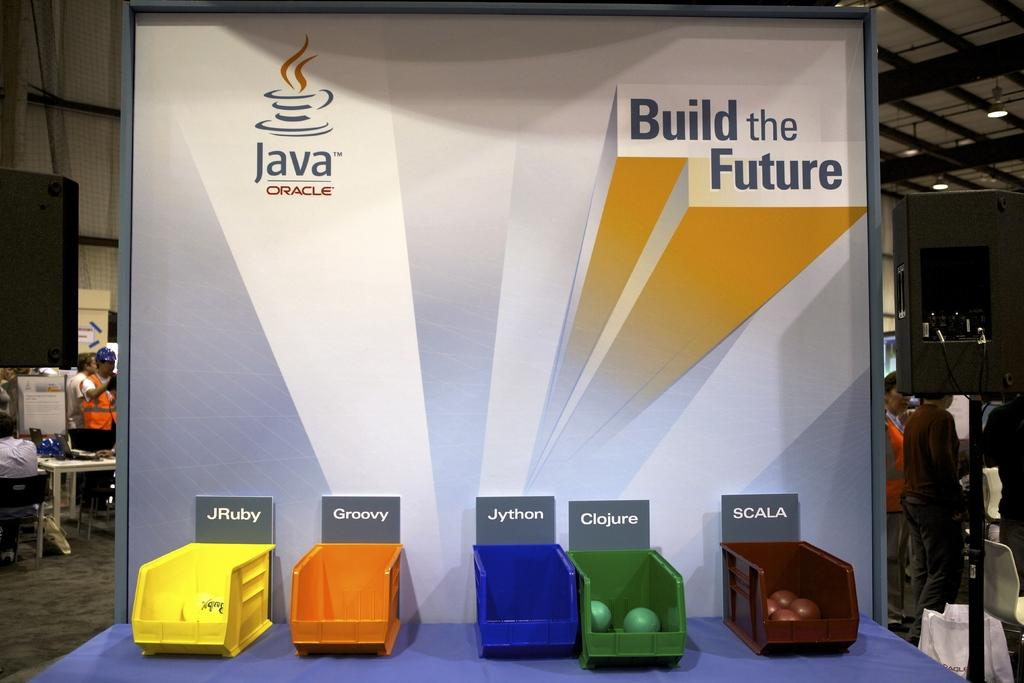<image>
Present a compact description of the photo's key features. A group of colored containers with the groovy written above the orange one. 